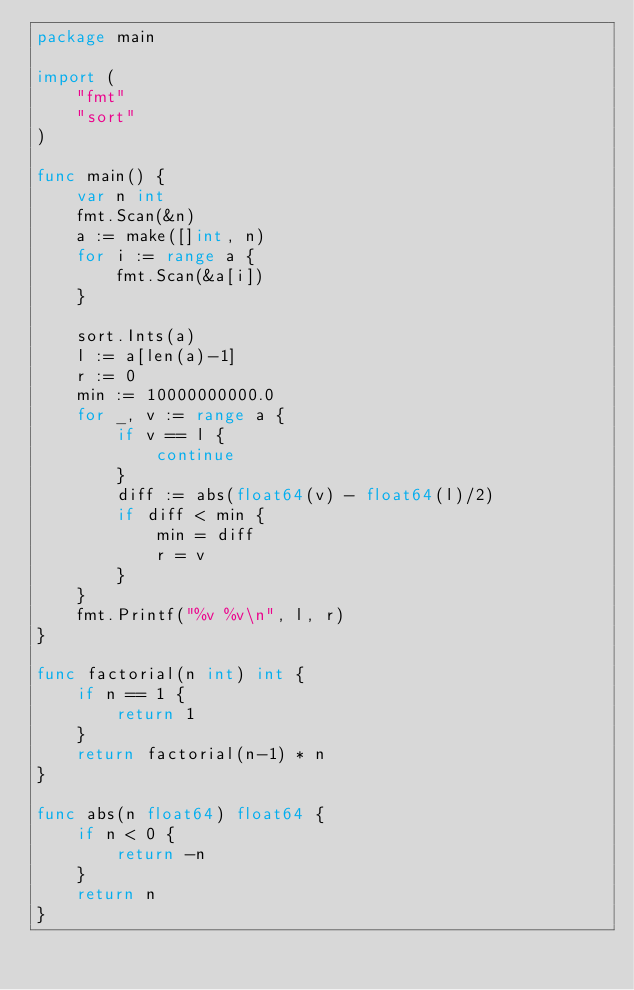<code> <loc_0><loc_0><loc_500><loc_500><_Go_>package main

import (
	"fmt"
	"sort"
)

func main() {
	var n int
	fmt.Scan(&n)
	a := make([]int, n)
	for i := range a {
		fmt.Scan(&a[i])
	}

	sort.Ints(a)
	l := a[len(a)-1]
	r := 0
	min := 10000000000.0
	for _, v := range a {
		if v == l {
			continue
		}
		diff := abs(float64(v) - float64(l)/2)
		if diff < min {
			min = diff
			r = v
		}
	}
	fmt.Printf("%v %v\n", l, r)
}

func factorial(n int) int {
	if n == 1 {
		return 1
	}
	return factorial(n-1) * n
}

func abs(n float64) float64 {
	if n < 0 {
		return -n
	}
	return n
}
</code> 